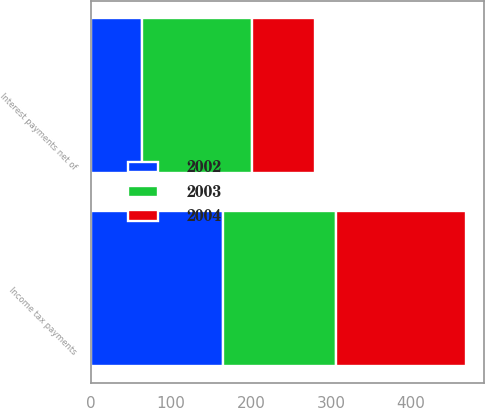Convert chart. <chart><loc_0><loc_0><loc_500><loc_500><stacked_bar_chart><ecel><fcel>Interest payments net of<fcel>Income tax payments<nl><fcel>2003<fcel>136.6<fcel>141.9<nl><fcel>2004<fcel>79.5<fcel>161.3<nl><fcel>2002<fcel>64.5<fcel>165.1<nl></chart> 